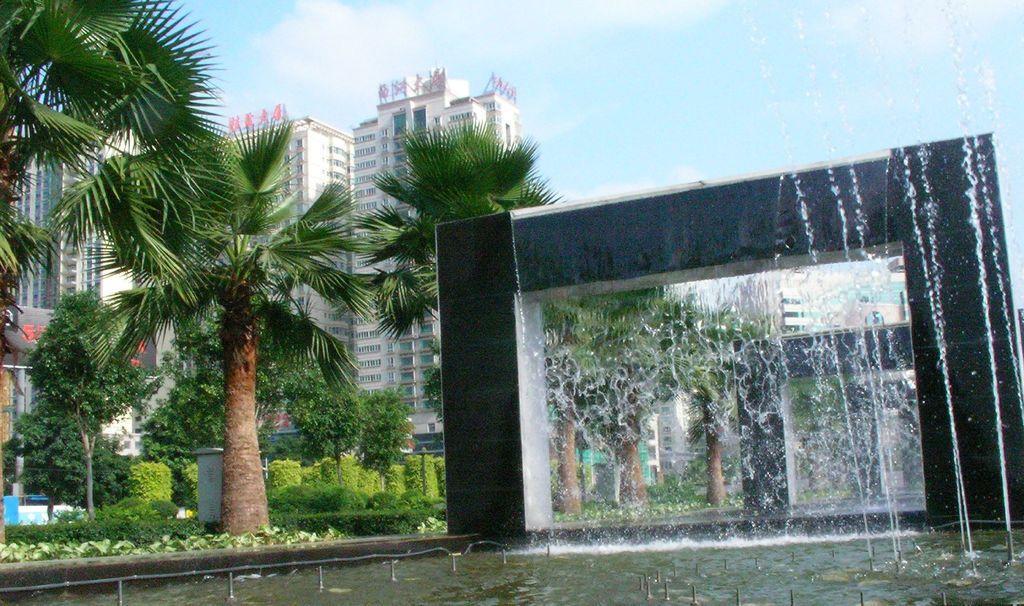Please provide a concise description of this image. As we can see in the image there is water, plants, trees and buildings. On the top there is sky. 